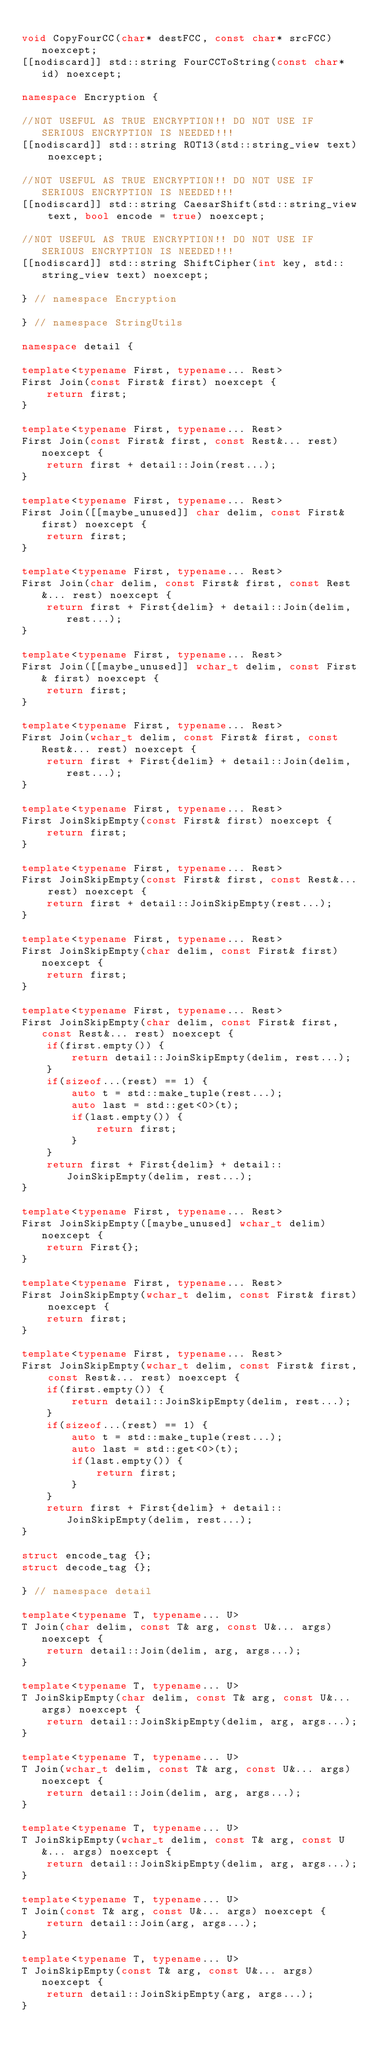<code> <loc_0><loc_0><loc_500><loc_500><_C++_>
void CopyFourCC(char* destFCC, const char* srcFCC) noexcept;
[[nodiscard]] std::string FourCCToString(const char* id) noexcept;

namespace Encryption {

//NOT USEFUL AS TRUE ENCRYPTION!! DO NOT USE IF SERIOUS ENCRYPTION IS NEEDED!!!
[[nodiscard]] std::string ROT13(std::string_view text) noexcept;

//NOT USEFUL AS TRUE ENCRYPTION!! DO NOT USE IF SERIOUS ENCRYPTION IS NEEDED!!!
[[nodiscard]] std::string CaesarShift(std::string_view text, bool encode = true) noexcept;

//NOT USEFUL AS TRUE ENCRYPTION!! DO NOT USE IF SERIOUS ENCRYPTION IS NEEDED!!!
[[nodiscard]] std::string ShiftCipher(int key, std::string_view text) noexcept;

} // namespace Encryption

} // namespace StringUtils

namespace detail {

template<typename First, typename... Rest>
First Join(const First& first) noexcept {
    return first;
}

template<typename First, typename... Rest>
First Join(const First& first, const Rest&... rest) noexcept {
    return first + detail::Join(rest...);
}

template<typename First, typename... Rest>
First Join([[maybe_unused]] char delim, const First& first) noexcept {
    return first;
}

template<typename First, typename... Rest>
First Join(char delim, const First& first, const Rest&... rest) noexcept {
    return first + First{delim} + detail::Join(delim, rest...);
}

template<typename First, typename... Rest>
First Join([[maybe_unused]] wchar_t delim, const First& first) noexcept {
    return first;
}

template<typename First, typename... Rest>
First Join(wchar_t delim, const First& first, const Rest&... rest) noexcept {
    return first + First{delim} + detail::Join(delim, rest...);
}

template<typename First, typename... Rest>
First JoinSkipEmpty(const First& first) noexcept {
    return first;
}

template<typename First, typename... Rest>
First JoinSkipEmpty(const First& first, const Rest&... rest) noexcept {
    return first + detail::JoinSkipEmpty(rest...);
}

template<typename First, typename... Rest>
First JoinSkipEmpty(char delim, const First& first) noexcept {
    return first;
}

template<typename First, typename... Rest>
First JoinSkipEmpty(char delim, const First& first, const Rest&... rest) noexcept {
    if(first.empty()) {
        return detail::JoinSkipEmpty(delim, rest...);
    }
    if(sizeof...(rest) == 1) {
        auto t = std::make_tuple(rest...);
        auto last = std::get<0>(t);
        if(last.empty()) {
            return first;
        }
    }
    return first + First{delim} + detail::JoinSkipEmpty(delim, rest...);
}

template<typename First, typename... Rest>
First JoinSkipEmpty([maybe_unused] wchar_t delim) noexcept {
    return First{};
}

template<typename First, typename... Rest>
First JoinSkipEmpty(wchar_t delim, const First& first) noexcept {
    return first;
}

template<typename First, typename... Rest>
First JoinSkipEmpty(wchar_t delim, const First& first, const Rest&... rest) noexcept {
    if(first.empty()) {
        return detail::JoinSkipEmpty(delim, rest...);
    }
    if(sizeof...(rest) == 1) {
        auto t = std::make_tuple(rest...);
        auto last = std::get<0>(t);
        if(last.empty()) {
            return first;
        }
    }
    return first + First{delim} + detail::JoinSkipEmpty(delim, rest...);
}

struct encode_tag {};
struct decode_tag {};

} // namespace detail

template<typename T, typename... U>
T Join(char delim, const T& arg, const U&... args) noexcept {
    return detail::Join(delim, arg, args...);
}

template<typename T, typename... U>
T JoinSkipEmpty(char delim, const T& arg, const U&... args) noexcept {
    return detail::JoinSkipEmpty(delim, arg, args...);
}

template<typename T, typename... U>
T Join(wchar_t delim, const T& arg, const U&... args) noexcept {
    return detail::Join(delim, arg, args...);
}

template<typename T, typename... U>
T JoinSkipEmpty(wchar_t delim, const T& arg, const U&... args) noexcept {
    return detail::JoinSkipEmpty(delim, arg, args...);
}

template<typename T, typename... U>
T Join(const T& arg, const U&... args) noexcept {
    return detail::Join(arg, args...);
}

template<typename T, typename... U>
T JoinSkipEmpty(const T& arg, const U&... args) noexcept {
    return detail::JoinSkipEmpty(arg, args...);
}
</code> 